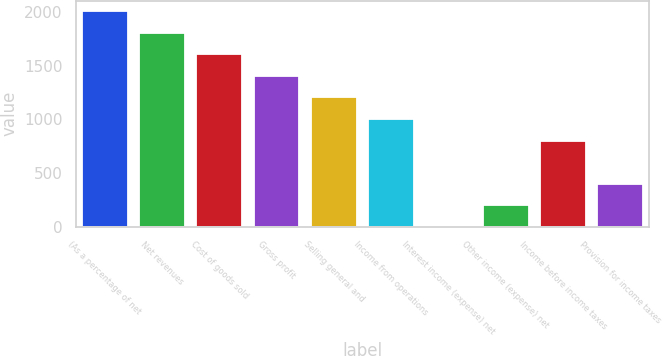Convert chart to OTSL. <chart><loc_0><loc_0><loc_500><loc_500><bar_chart><fcel>(As a percentage of net<fcel>Net revenues<fcel>Cost of goods sold<fcel>Gross profit<fcel>Selling general and<fcel>Income from operations<fcel>Interest income (expense) net<fcel>Other income (expense) net<fcel>Income before income taxes<fcel>Provision for income taxes<nl><fcel>2008<fcel>1807.21<fcel>1606.42<fcel>1405.63<fcel>1204.84<fcel>1004.05<fcel>0.1<fcel>200.89<fcel>803.26<fcel>401.68<nl></chart> 